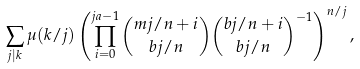<formula> <loc_0><loc_0><loc_500><loc_500>\sum _ { j | k } \mu ( k / j ) \left ( \prod _ { i = 0 } ^ { j a - 1 } \binom { m j / n + i } { b j / n } \binom { b j / n + i } { b j / n } ^ { - 1 } \right ) ^ { n / j } ,</formula> 